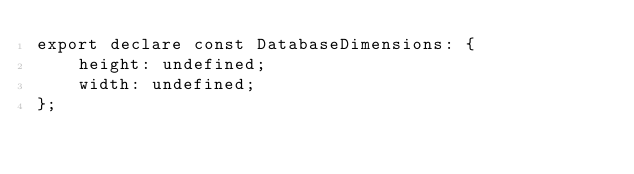Convert code to text. <code><loc_0><loc_0><loc_500><loc_500><_TypeScript_>export declare const DatabaseDimensions: {
    height: undefined;
    width: undefined;
};
</code> 